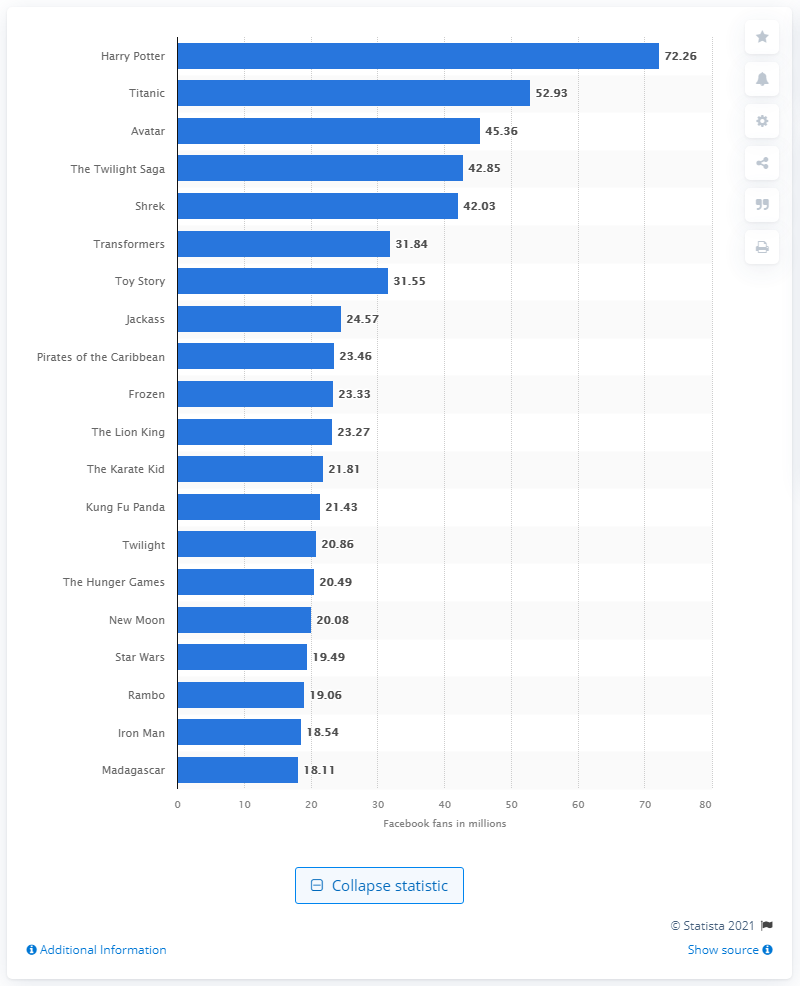Draw attention to some important aspects in this diagram. Titanic, the movie, had the most fans on Facebook. Harry Potter had 72,260 fans on Facebook. 